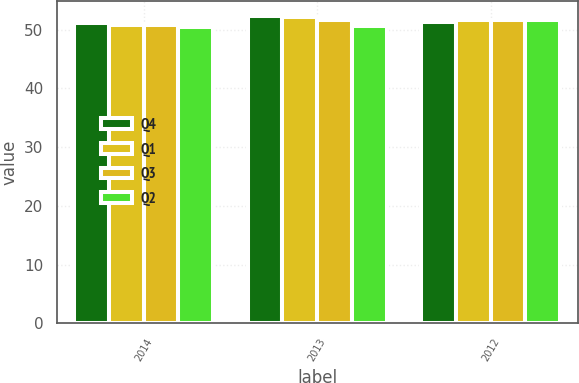Convert chart to OTSL. <chart><loc_0><loc_0><loc_500><loc_500><stacked_bar_chart><ecel><fcel>2014<fcel>2013<fcel>2012<nl><fcel>Q4<fcel>51.2<fcel>52.3<fcel>51.3<nl><fcel>Q1<fcel>50.8<fcel>52.2<fcel>51.6<nl><fcel>Q3<fcel>50.8<fcel>51.7<fcel>51.6<nl><fcel>Q2<fcel>50.5<fcel>50.6<fcel>51.6<nl></chart> 